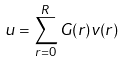<formula> <loc_0><loc_0><loc_500><loc_500>u = \sum _ { r = 0 } ^ { R } G ( r ) v ( r )</formula> 